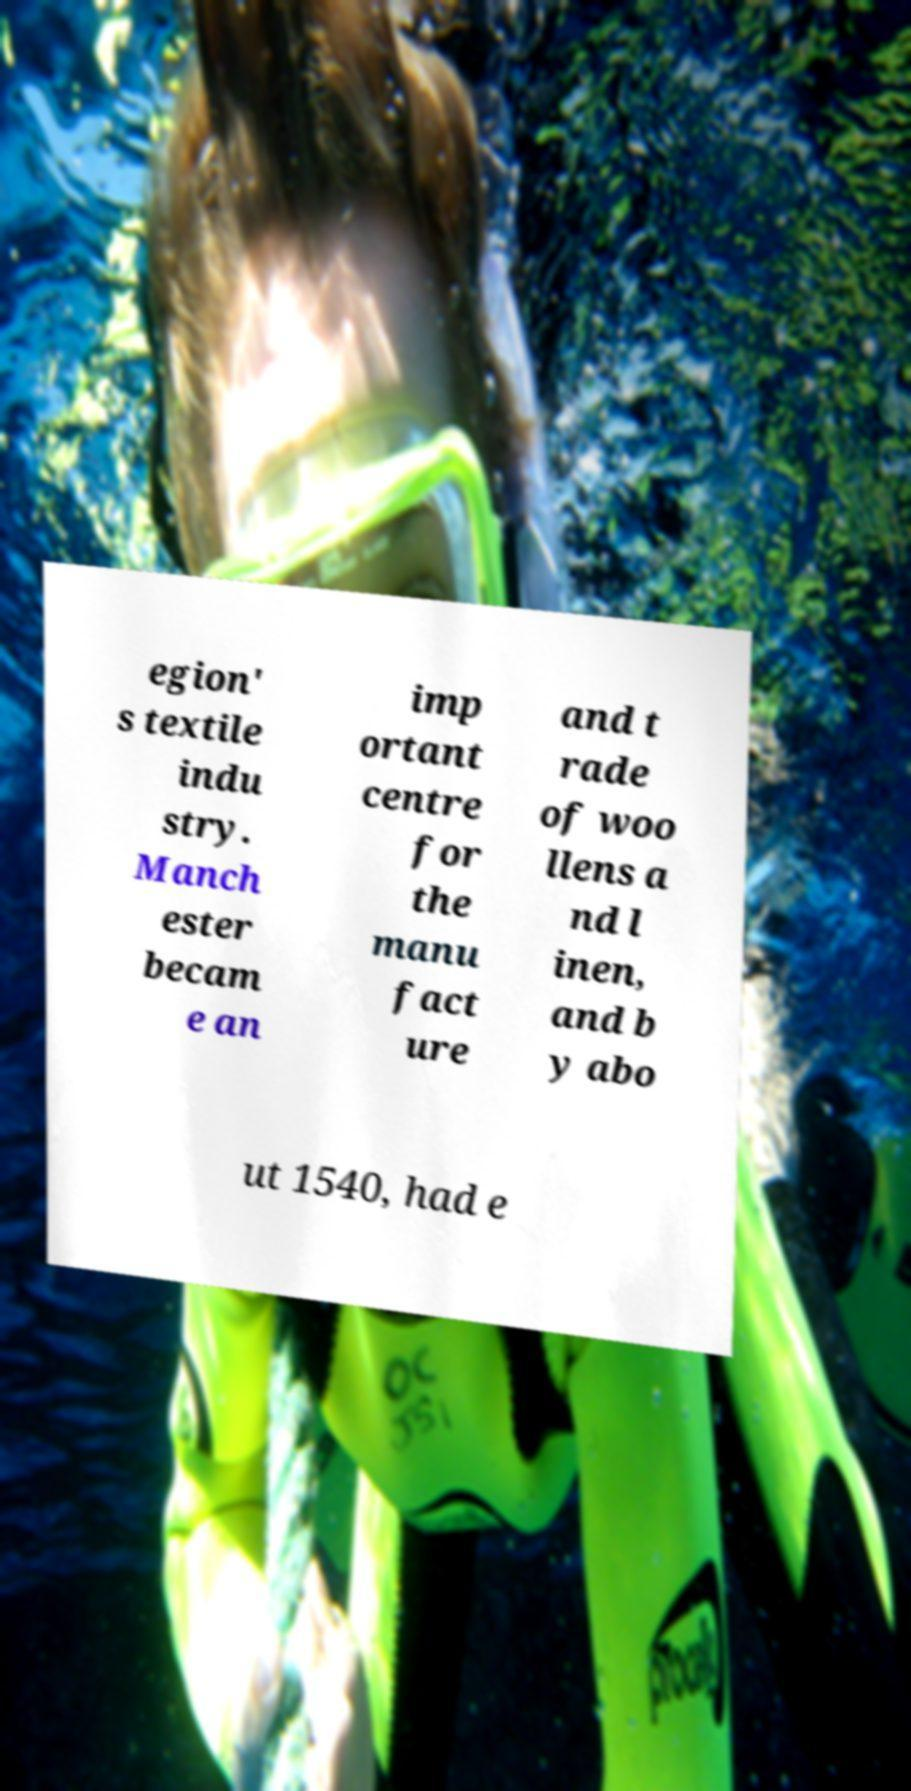Please identify and transcribe the text found in this image. egion' s textile indu stry. Manch ester becam e an imp ortant centre for the manu fact ure and t rade of woo llens a nd l inen, and b y abo ut 1540, had e 